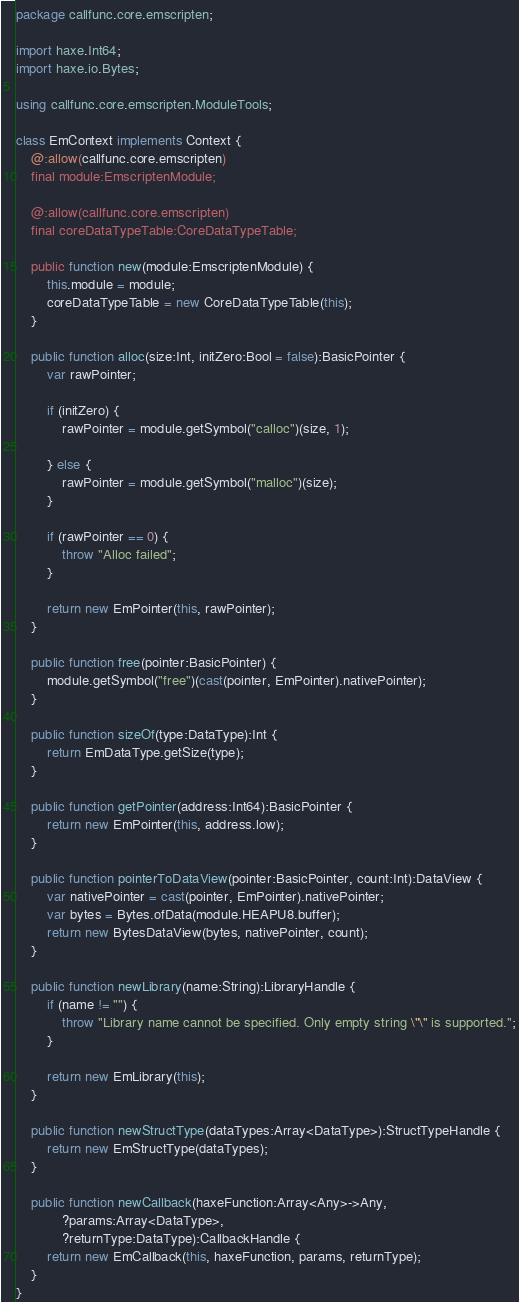<code> <loc_0><loc_0><loc_500><loc_500><_Haxe_>package callfunc.core.emscripten;

import haxe.Int64;
import haxe.io.Bytes;

using callfunc.core.emscripten.ModuleTools;

class EmContext implements Context {
    @:allow(callfunc.core.emscripten)
    final module:EmscriptenModule;

    @:allow(callfunc.core.emscripten)
    final coreDataTypeTable:CoreDataTypeTable;

    public function new(module:EmscriptenModule) {
        this.module = module;
        coreDataTypeTable = new CoreDataTypeTable(this);
    }

    public function alloc(size:Int, initZero:Bool = false):BasicPointer {
        var rawPointer;

        if (initZero) {
            rawPointer = module.getSymbol("calloc")(size, 1);

        } else {
            rawPointer = module.getSymbol("malloc")(size);
        }

        if (rawPointer == 0) {
            throw "Alloc failed";
        }

        return new EmPointer(this, rawPointer);
    }

    public function free(pointer:BasicPointer) {
        module.getSymbol("free")(cast(pointer, EmPointer).nativePointer);
    }

    public function sizeOf(type:DataType):Int {
        return EmDataType.getSize(type);
    }

    public function getPointer(address:Int64):BasicPointer {
        return new EmPointer(this, address.low);
    }

    public function pointerToDataView(pointer:BasicPointer, count:Int):DataView {
        var nativePointer = cast(pointer, EmPointer).nativePointer;
        var bytes = Bytes.ofData(module.HEAPU8.buffer);
        return new BytesDataView(bytes, nativePointer, count);
    }

    public function newLibrary(name:String):LibraryHandle {
        if (name != "") {
            throw "Library name cannot be specified. Only empty string \"\" is supported.";
        }

        return new EmLibrary(this);
    }

    public function newStructType(dataTypes:Array<DataType>):StructTypeHandle {
        return new EmStructType(dataTypes);
    }

    public function newCallback(haxeFunction:Array<Any>->Any,
            ?params:Array<DataType>,
            ?returnType:DataType):CallbackHandle {
        return new EmCallback(this, haxeFunction, params, returnType);
    }
}
</code> 